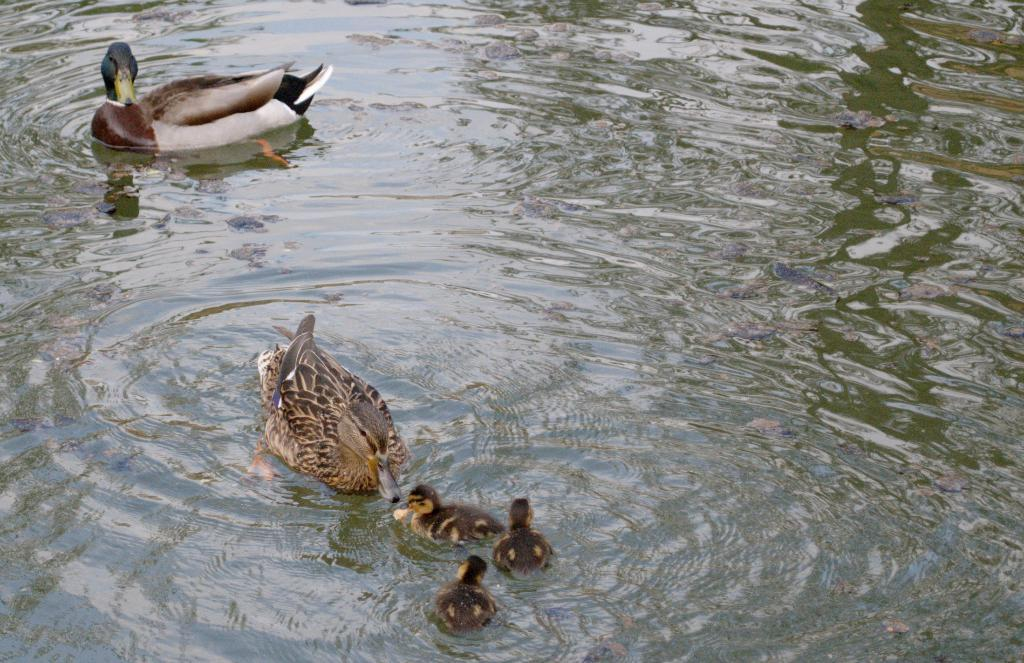What type of animals are present in the image? There are ducks and ducklings in the image. Where are the ducks and ducklings located? The ducks and ducklings are on the water. Can you describe the relationship between the ducks and ducklings in the image? The ducks and ducklings are likely related, as ducklings are the offspring of ducks. What is the tendency of the cannon in the image? There is no cannon present in the image. Can you describe the boat in the image? There is no boat present in the image; it features ducks and ducklings on the water. 